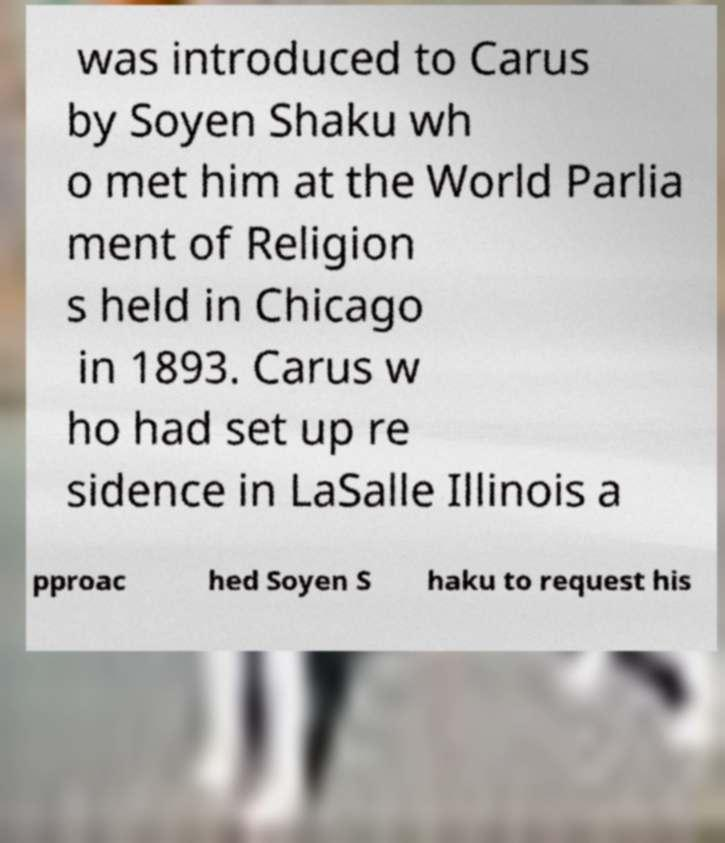Please read and relay the text visible in this image. What does it say? was introduced to Carus by Soyen Shaku wh o met him at the World Parlia ment of Religion s held in Chicago in 1893. Carus w ho had set up re sidence in LaSalle Illinois a pproac hed Soyen S haku to request his 